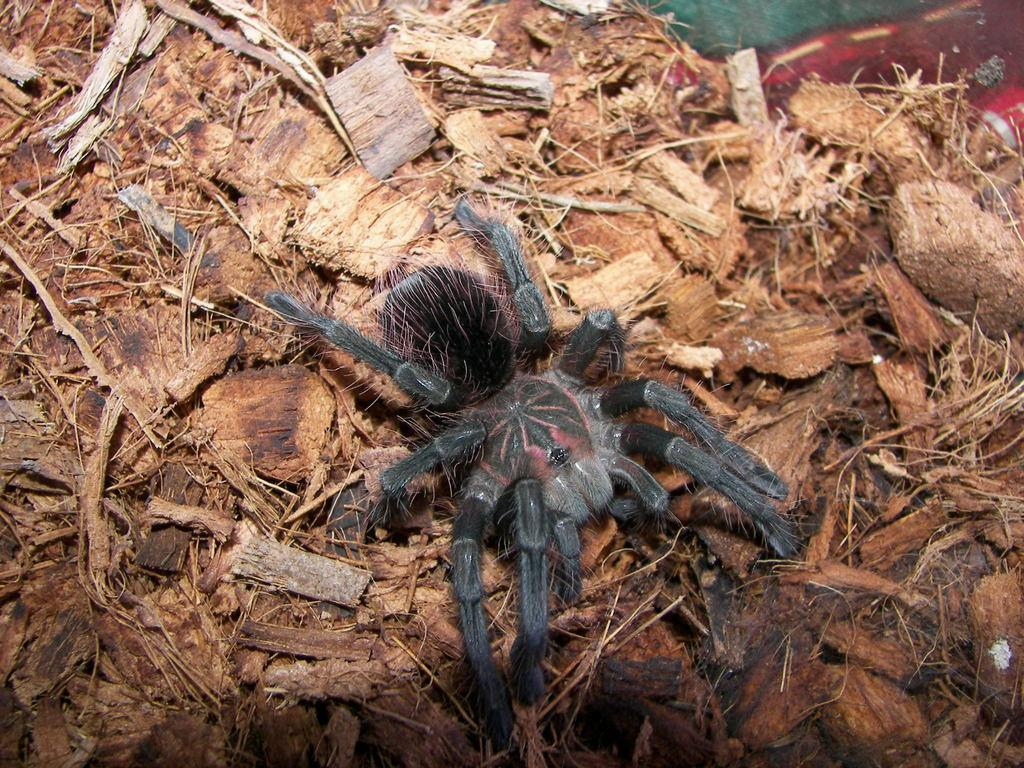What type of creature can be seen in the image? There is an insect in the image. Where is the insect located? The insect is on the surface of dry grass. What other objects are present in the image? Wooden pieces are present in the image. What type of chair is visible in the image? There is no chair present in the image; it only features an insect on dry grass and wooden pieces. 